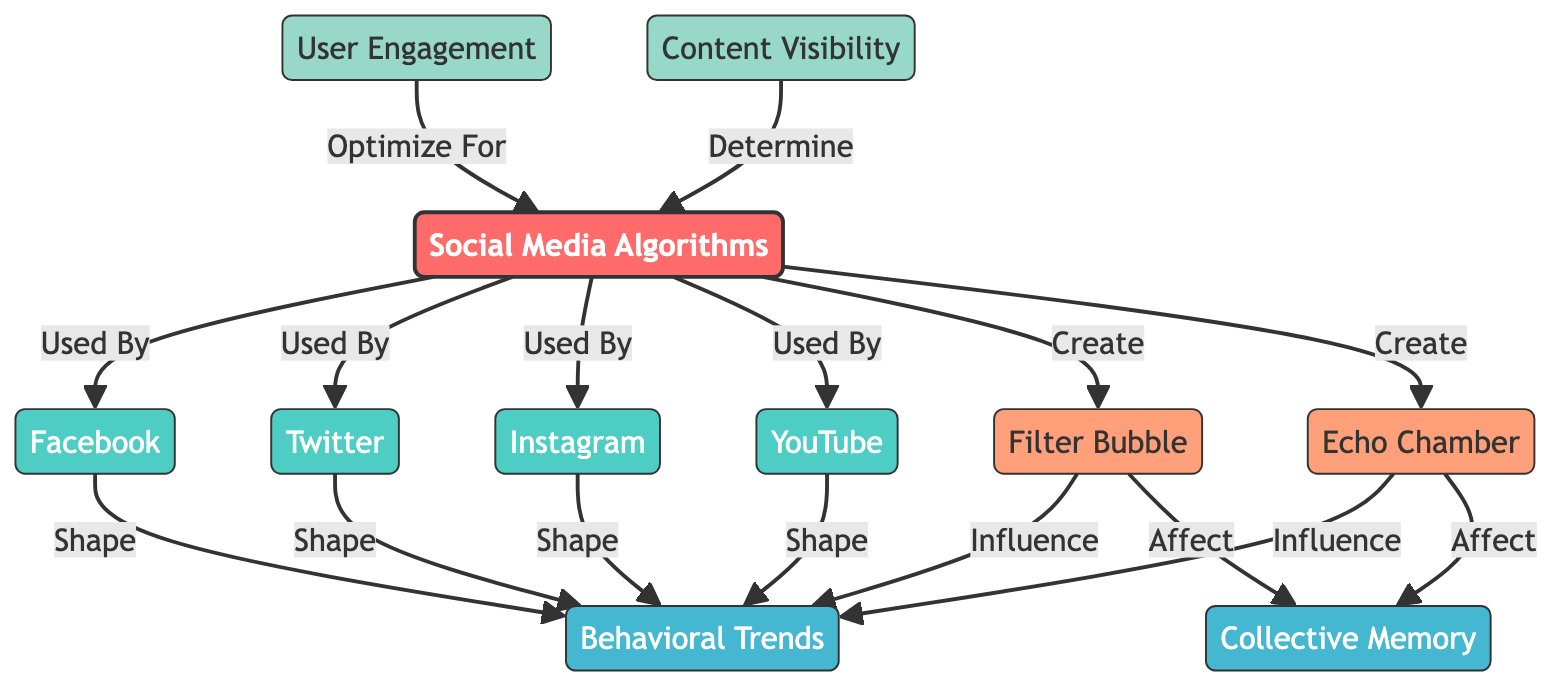What are the four major platforms listed in the diagram? The diagram explicitly names four platforms: Facebook, Twitter, Instagram, and YouTube. These nodes fall under the "Used By" relationship stemming from the "Social Media Algorithms" node.
Answer: Facebook, Twitter, Instagram, YouTube How many types of behavioral influences are identified in the diagram? The diagram lists two specific concepts under the "Create" relationship from "Social Media Algorithms": filter bubble and echo chamber, totaling two behavioral influences.
Answer: Two What influences collective memory according to the diagram? The diagram shows that both filter bubbles and echo chambers affect collective memory, establishing a direct connection from these concepts to "Collective Memory."
Answer: Filter bubble and echo chamber Which metric determines algorithms in the diagram? The diagram indicates that "Content Visibility" determines the algorithms as depicted by the arrow originating from this metric pointing to the "Social Media Algorithms" node.
Answer: Content Visibility What is the relationship between user engagement and social media algorithms? The diagram illustrates that user engagement is optimized for algorithms, indicating a direct influence where engagement is shaped by how algorithms are designed.
Answer: Optimized For How do the major platforms influence behavioral trends? The flow from each platform (Facebook, Twitter, Instagram, YouTube) towards behavioral trends indicates that these platforms shape the trends as denoted on the directed edges in the diagram.
Answer: Shape What do filter bubbles and echo chambers create? The diagram states that social media algorithms create both filter bubbles and echo chambers, which are two conceptual nodes arising from the algorithms node.
Answer: Filter bubble and echo chamber Name one of the categories of influence mentioned in the diagram. The diagram categorically identifies "Behavioral Trends" and "Collective Memory" as the two categories influenced by the social media algorithms and related concepts.
Answer: Behavioral Trends or Collective Memory 